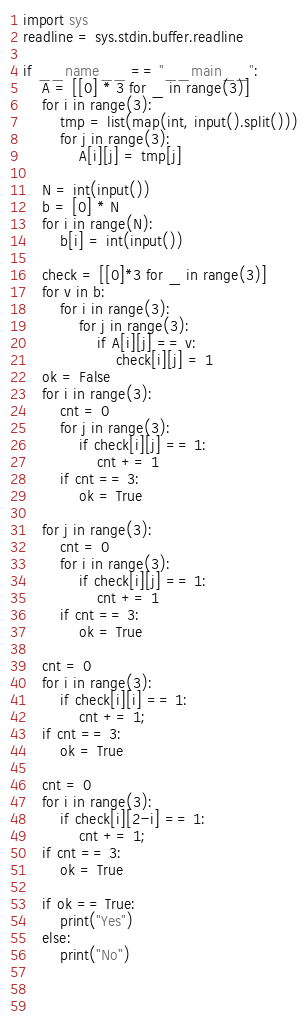Convert code to text. <code><loc_0><loc_0><loc_500><loc_500><_Python_>import sys
readline = sys.stdin.buffer.readline

if __name__ == "__main__":
    A = [[0] * 3 for _ in range(3)]
    for i in range(3):
        tmp = list(map(int, input().split()))
        for j in range(3):
            A[i][j] = tmp[j]
    
    N = int(input())
    b = [0] * N
    for i in range(N):
        b[i] = int(input())

    check = [[0]*3 for _ in range(3)]
    for v in b:
        for i in range(3):
            for j in range(3):
                if A[i][j] == v:
                    check[i][j] = 1
    ok = False
    for i in range(3):
        cnt = 0
        for j in range(3):
            if check[i][j] == 1:
                cnt += 1
        if cnt == 3:
            ok = True

    for j in range(3):
        cnt = 0
        for i in range(3):
            if check[i][j] == 1:
                cnt += 1
        if cnt == 3:
            ok = True
    
    cnt = 0
    for i in range(3):
        if check[i][i] == 1:
            cnt += 1;
    if cnt == 3:
        ok = True
    
    cnt = 0
    for i in range(3):
        if check[i][2-i] == 1:
            cnt += 1;
    if cnt == 3:
        ok = True
    
    if ok == True:
        print("Yes")
    else:
        print("No")


    


</code> 